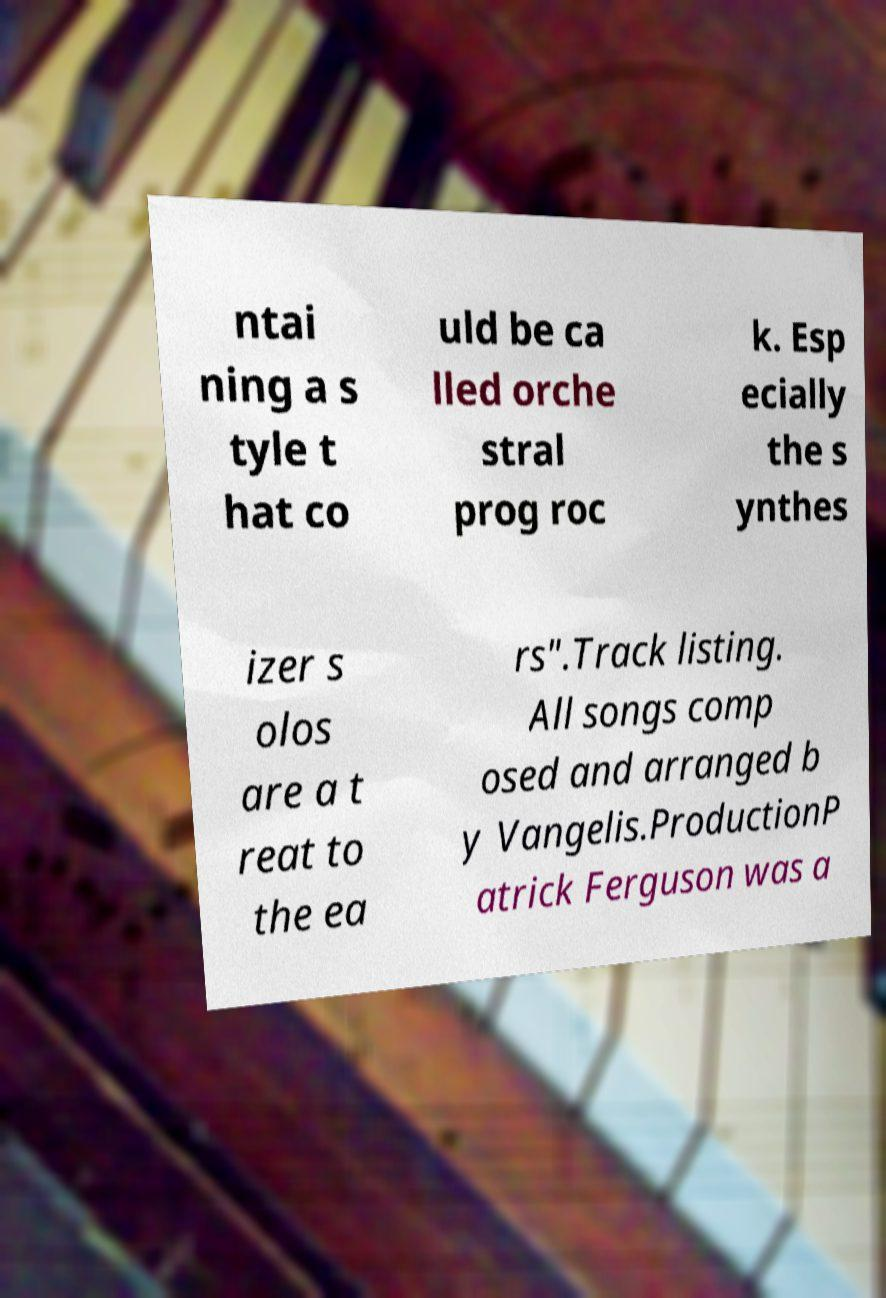For documentation purposes, I need the text within this image transcribed. Could you provide that? ntai ning a s tyle t hat co uld be ca lled orche stral prog roc k. Esp ecially the s ynthes izer s olos are a t reat to the ea rs".Track listing. All songs comp osed and arranged b y Vangelis.ProductionP atrick Ferguson was a 